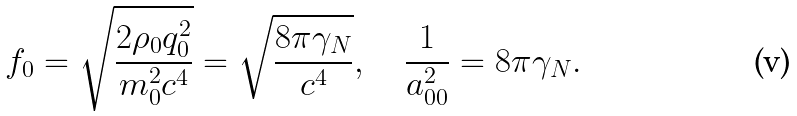<formula> <loc_0><loc_0><loc_500><loc_500>f _ { 0 } = \sqrt { \frac { 2 \rho _ { 0 } q _ { 0 } ^ { 2 } } { m _ { 0 } ^ { 2 } c ^ { 4 } } } = \sqrt { \frac { 8 \pi \gamma _ { N } } { c ^ { 4 } } } , \quad \frac { 1 } { a _ { 0 0 } ^ { 2 } } = 8 \pi \gamma _ { N } .</formula> 